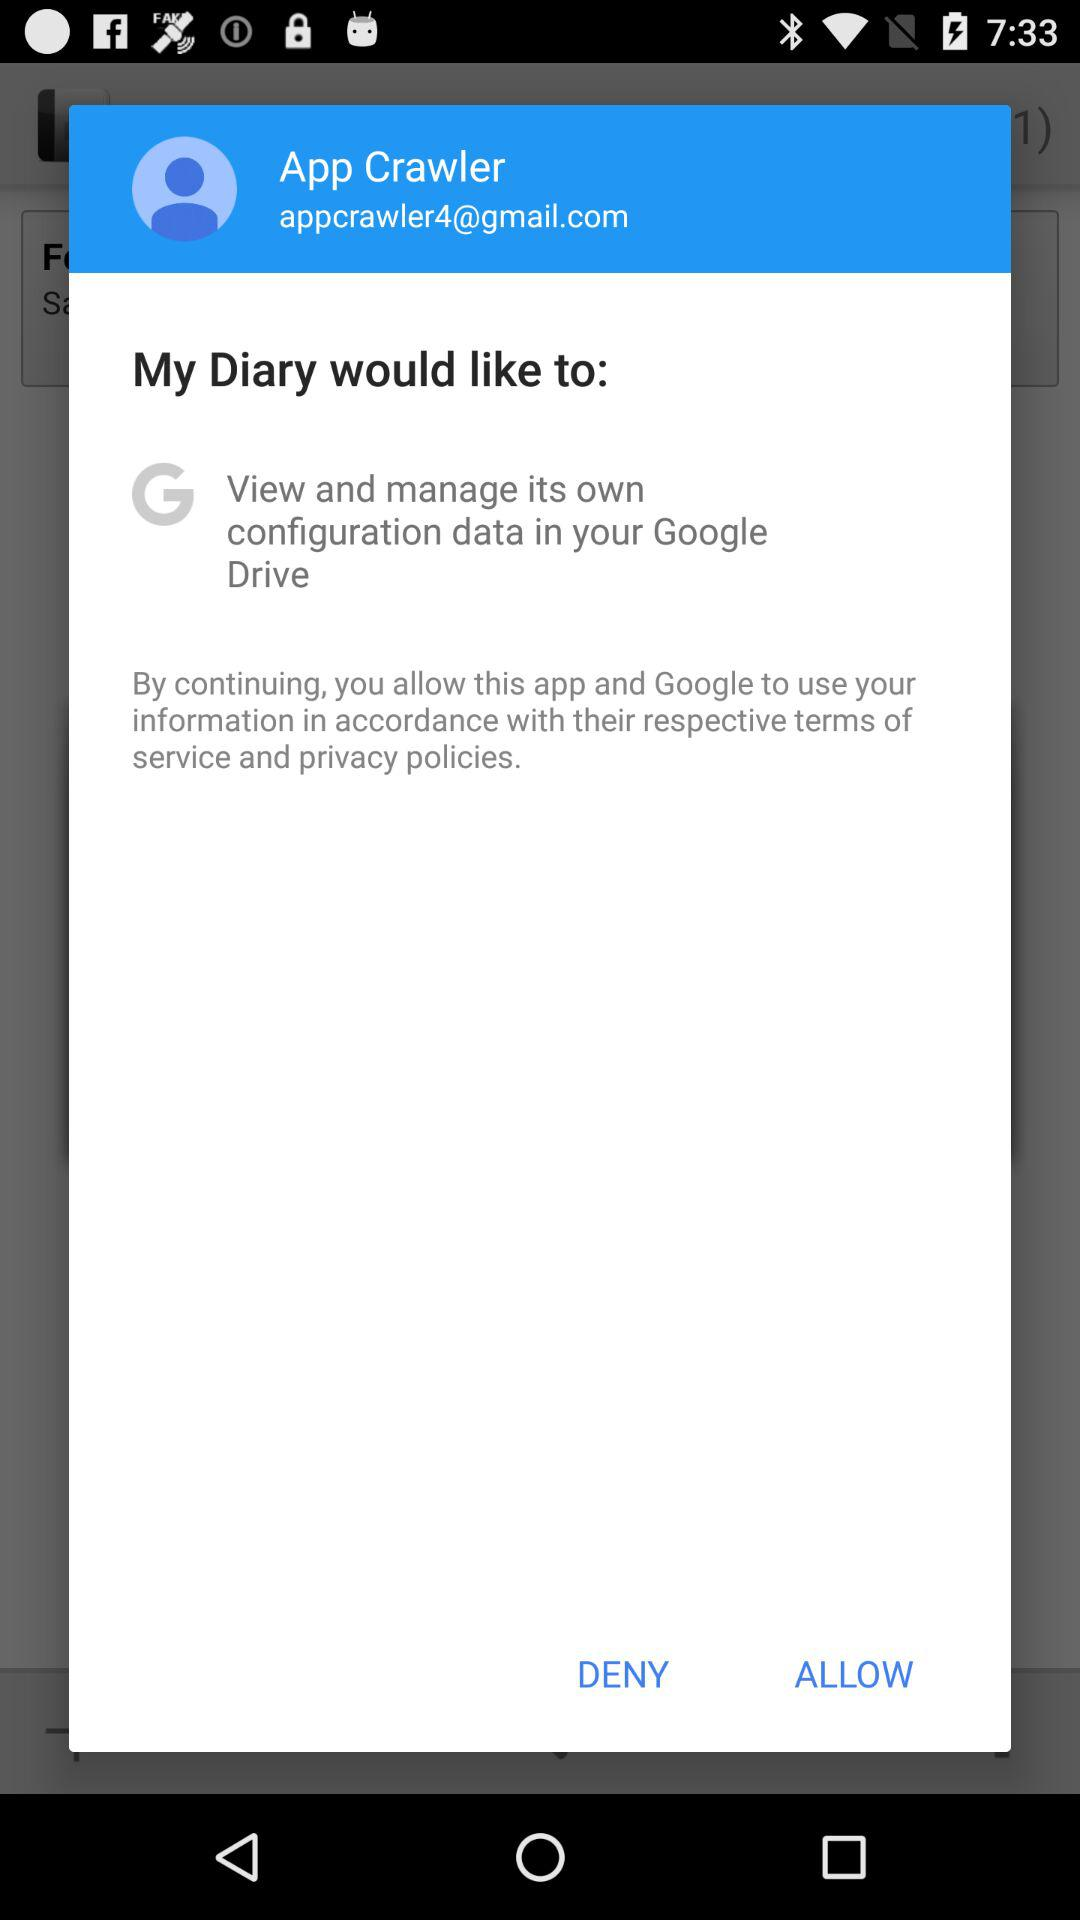What is the name of the user? The name of the user is App Crawler. 